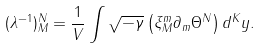<formula> <loc_0><loc_0><loc_500><loc_500>( \lambda ^ { - 1 } ) ^ { N } _ { M } = \frac { 1 } { V } \int \sqrt { - \gamma } \left ( \xi ^ { m } _ { M } \partial _ { m } \Theta ^ { N } \right ) d ^ { K } y .</formula> 